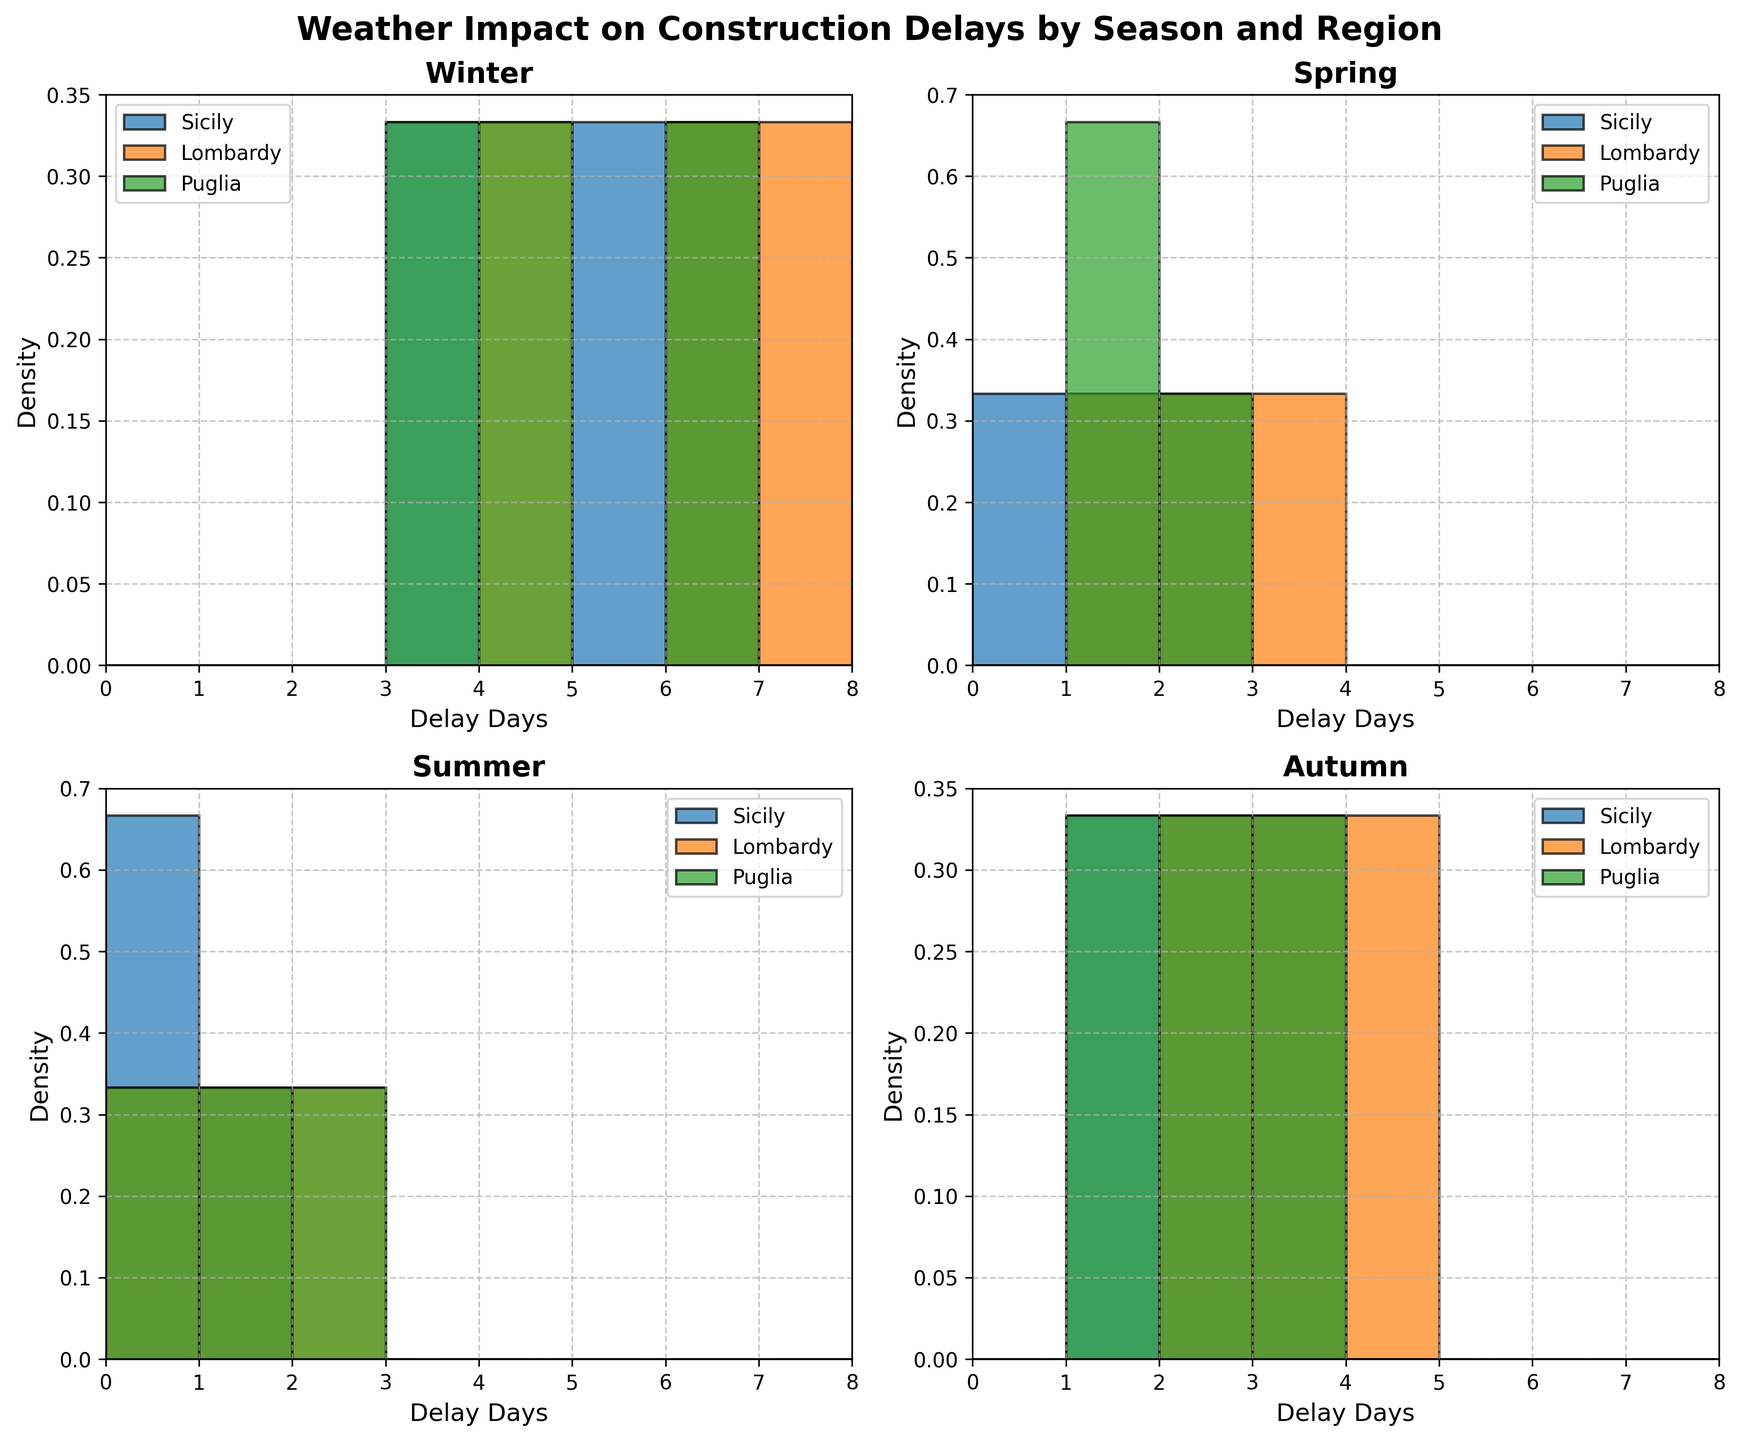What is the title of the figure? The title is displayed at the top of the figure and reads, "Weather Impact on Construction Delays by Season and Region".
Answer: Weather Impact on Construction Delays by Season and Region Which season shows the histogram for construction delays in Lombardy with the highest density? In the winter subplot, Lombardy has delays primarily focused around 4 and 6 days with the highest density.
Answer: Winter How do the construction delays in Sicily during summer compare to other regions? In the summer subplot, Sicily has fewer delays (0-1 days) whereas other regions like Lombardy and Puglia show delays of up to 2 days.
Answer: Fewer delays What is the range of delay days shown on the x-axis of each subplot? Each subplot has an x-axis that ranges from 0 to 8 days of delay. This is seen by the x-axis ticks marked from 0 to 8 in each subplot.
Answer: 0-8 days Which region shows the most variation in delays during autumn? In the autumn subplot, Lombardy has delays ranging from 2 to 4 days, showing more variation compared to Sicily and Puglia.
Answer: Lombardy Are there any regions with delay days in winter that exceed the 6-day mark? Yes, both Sicily and Lombardy show delay days exceeding 6 days during winter in the density plot.
Answer: Yes Compare the density of delay days during spring between Sicily and Lombardy. In the spring subplot, Sicily shows lower densities with delays primarily at 0-2 days, whereas Lombardy has delays at 1-3 days with a slightly higher density.
Answer: Lombardy has higher density Which season has the smallest density for delay days across all regions? The summer subplot has the smallest density for delay days across all regions as most delay days are concentrated at 0-1 days.
Answer: Summer Which region and season combination exhibits delays mostly due to rain? Sicily during winter shows high delay days predominantly due to rain, with visible peaks at 5 and 6 days in the histogram.
Answer: Sicily in winter 